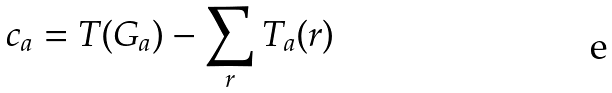Convert formula to latex. <formula><loc_0><loc_0><loc_500><loc_500>c _ { a } = T ( G _ { a } ) - \sum _ { r } T _ { a } ( r )</formula> 